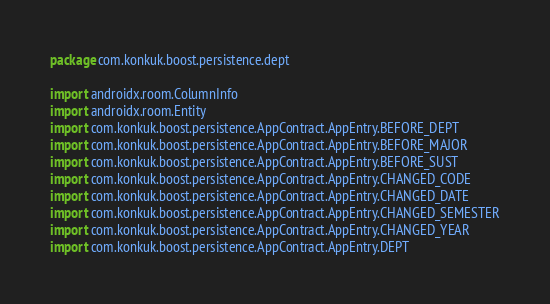<code> <loc_0><loc_0><loc_500><loc_500><_Kotlin_>package com.konkuk.boost.persistence.dept

import androidx.room.ColumnInfo
import androidx.room.Entity
import com.konkuk.boost.persistence.AppContract.AppEntry.BEFORE_DEPT
import com.konkuk.boost.persistence.AppContract.AppEntry.BEFORE_MAJOR
import com.konkuk.boost.persistence.AppContract.AppEntry.BEFORE_SUST
import com.konkuk.boost.persistence.AppContract.AppEntry.CHANGED_CODE
import com.konkuk.boost.persistence.AppContract.AppEntry.CHANGED_DATE
import com.konkuk.boost.persistence.AppContract.AppEntry.CHANGED_SEMESTER
import com.konkuk.boost.persistence.AppContract.AppEntry.CHANGED_YEAR
import com.konkuk.boost.persistence.AppContract.AppEntry.DEPT</code> 